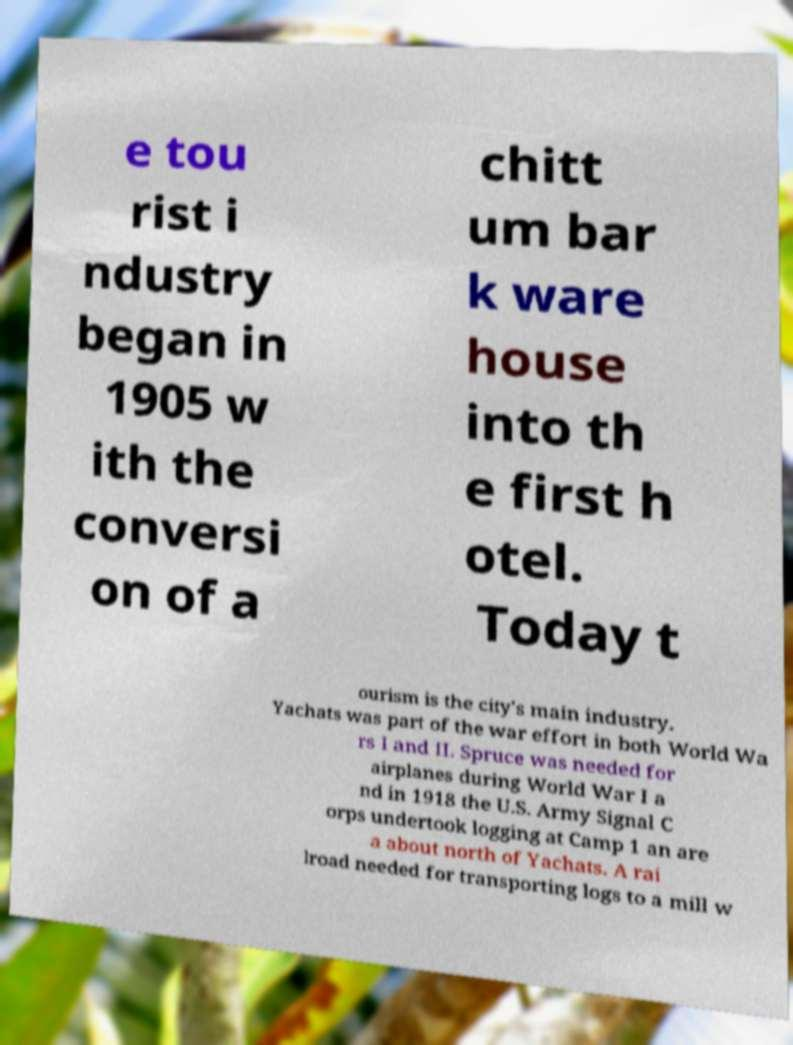Could you assist in decoding the text presented in this image and type it out clearly? e tou rist i ndustry began in 1905 w ith the conversi on of a chitt um bar k ware house into th e first h otel. Today t ourism is the city's main industry. Yachats was part of the war effort in both World Wa rs I and II. Spruce was needed for airplanes during World War I a nd in 1918 the U.S. Army Signal C orps undertook logging at Camp 1 an are a about north of Yachats. A rai lroad needed for transporting logs to a mill w 